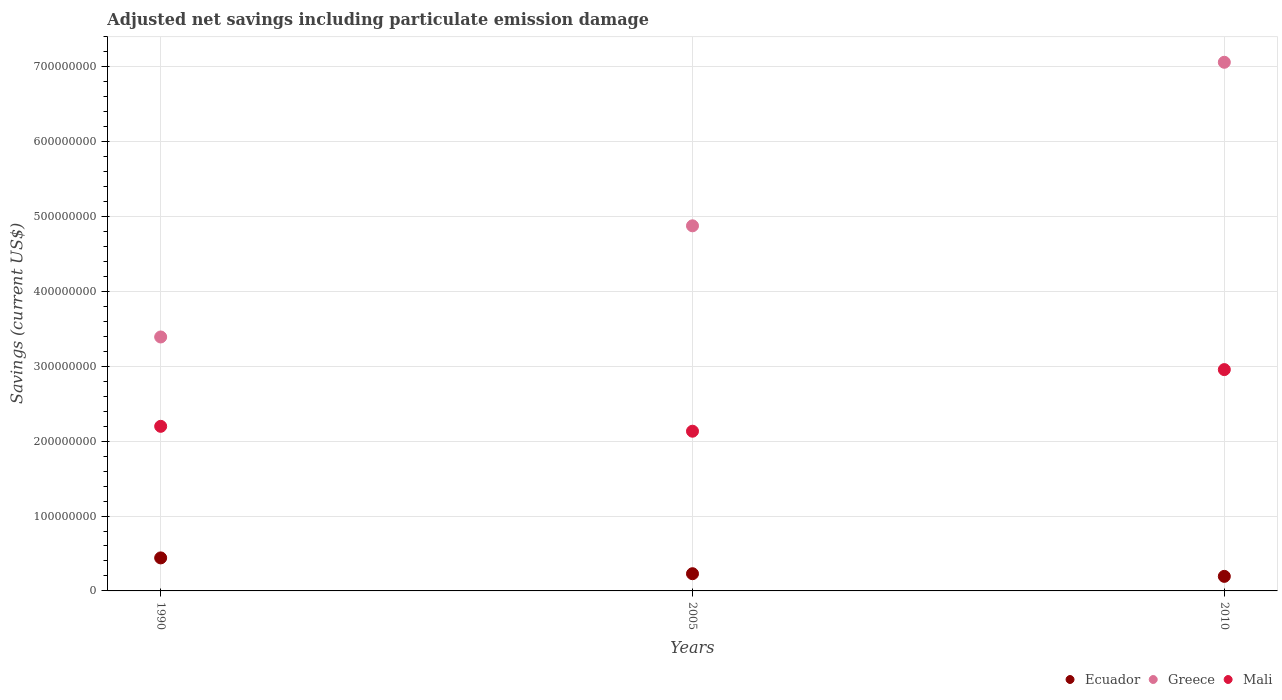Is the number of dotlines equal to the number of legend labels?
Give a very brief answer. Yes. What is the net savings in Greece in 2005?
Give a very brief answer. 4.88e+08. Across all years, what is the maximum net savings in Ecuador?
Ensure brevity in your answer.  4.41e+07. Across all years, what is the minimum net savings in Ecuador?
Offer a terse response. 1.94e+07. What is the total net savings in Mali in the graph?
Provide a short and direct response. 7.29e+08. What is the difference between the net savings in Ecuador in 1990 and that in 2010?
Provide a short and direct response. 2.47e+07. What is the difference between the net savings in Mali in 1990 and the net savings in Greece in 2010?
Provide a succinct answer. -4.86e+08. What is the average net savings in Greece per year?
Make the answer very short. 5.11e+08. In the year 2005, what is the difference between the net savings in Mali and net savings in Ecuador?
Provide a succinct answer. 1.90e+08. In how many years, is the net savings in Mali greater than 80000000 US$?
Keep it short and to the point. 3. What is the ratio of the net savings in Greece in 1990 to that in 2005?
Offer a terse response. 0.7. Is the net savings in Mali in 2005 less than that in 2010?
Your answer should be very brief. Yes. Is the difference between the net savings in Mali in 2005 and 2010 greater than the difference between the net savings in Ecuador in 2005 and 2010?
Provide a succinct answer. No. What is the difference between the highest and the second highest net savings in Ecuador?
Keep it short and to the point. 2.11e+07. What is the difference between the highest and the lowest net savings in Ecuador?
Provide a short and direct response. 2.47e+07. Is it the case that in every year, the sum of the net savings in Greece and net savings in Ecuador  is greater than the net savings in Mali?
Offer a very short reply. Yes. Is the net savings in Greece strictly greater than the net savings in Mali over the years?
Offer a very short reply. Yes. Does the graph contain any zero values?
Offer a terse response. No. Does the graph contain grids?
Your response must be concise. Yes. Where does the legend appear in the graph?
Give a very brief answer. Bottom right. What is the title of the graph?
Offer a terse response. Adjusted net savings including particulate emission damage. What is the label or title of the Y-axis?
Your answer should be very brief. Savings (current US$). What is the Savings (current US$) of Ecuador in 1990?
Give a very brief answer. 4.41e+07. What is the Savings (current US$) of Greece in 1990?
Offer a terse response. 3.39e+08. What is the Savings (current US$) of Mali in 1990?
Ensure brevity in your answer.  2.20e+08. What is the Savings (current US$) of Ecuador in 2005?
Your answer should be very brief. 2.30e+07. What is the Savings (current US$) of Greece in 2005?
Offer a very short reply. 4.88e+08. What is the Savings (current US$) of Mali in 2005?
Your response must be concise. 2.13e+08. What is the Savings (current US$) in Ecuador in 2010?
Provide a succinct answer. 1.94e+07. What is the Savings (current US$) of Greece in 2010?
Your response must be concise. 7.06e+08. What is the Savings (current US$) in Mali in 2010?
Make the answer very short. 2.96e+08. Across all years, what is the maximum Savings (current US$) in Ecuador?
Your response must be concise. 4.41e+07. Across all years, what is the maximum Savings (current US$) in Greece?
Offer a terse response. 7.06e+08. Across all years, what is the maximum Savings (current US$) of Mali?
Give a very brief answer. 2.96e+08. Across all years, what is the minimum Savings (current US$) of Ecuador?
Your answer should be compact. 1.94e+07. Across all years, what is the minimum Savings (current US$) of Greece?
Your response must be concise. 3.39e+08. Across all years, what is the minimum Savings (current US$) of Mali?
Keep it short and to the point. 2.13e+08. What is the total Savings (current US$) of Ecuador in the graph?
Give a very brief answer. 8.65e+07. What is the total Savings (current US$) of Greece in the graph?
Ensure brevity in your answer.  1.53e+09. What is the total Savings (current US$) in Mali in the graph?
Make the answer very short. 7.29e+08. What is the difference between the Savings (current US$) in Ecuador in 1990 and that in 2005?
Give a very brief answer. 2.11e+07. What is the difference between the Savings (current US$) in Greece in 1990 and that in 2005?
Offer a terse response. -1.48e+08. What is the difference between the Savings (current US$) in Mali in 1990 and that in 2005?
Offer a very short reply. 6.53e+06. What is the difference between the Savings (current US$) of Ecuador in 1990 and that in 2010?
Your answer should be compact. 2.47e+07. What is the difference between the Savings (current US$) in Greece in 1990 and that in 2010?
Your answer should be compact. -3.67e+08. What is the difference between the Savings (current US$) in Mali in 1990 and that in 2010?
Offer a very short reply. -7.58e+07. What is the difference between the Savings (current US$) in Ecuador in 2005 and that in 2010?
Your response must be concise. 3.54e+06. What is the difference between the Savings (current US$) of Greece in 2005 and that in 2010?
Your response must be concise. -2.18e+08. What is the difference between the Savings (current US$) in Mali in 2005 and that in 2010?
Make the answer very short. -8.23e+07. What is the difference between the Savings (current US$) of Ecuador in 1990 and the Savings (current US$) of Greece in 2005?
Give a very brief answer. -4.44e+08. What is the difference between the Savings (current US$) of Ecuador in 1990 and the Savings (current US$) of Mali in 2005?
Offer a very short reply. -1.69e+08. What is the difference between the Savings (current US$) of Greece in 1990 and the Savings (current US$) of Mali in 2005?
Ensure brevity in your answer.  1.26e+08. What is the difference between the Savings (current US$) in Ecuador in 1990 and the Savings (current US$) in Greece in 2010?
Ensure brevity in your answer.  -6.62e+08. What is the difference between the Savings (current US$) of Ecuador in 1990 and the Savings (current US$) of Mali in 2010?
Your answer should be very brief. -2.51e+08. What is the difference between the Savings (current US$) in Greece in 1990 and the Savings (current US$) in Mali in 2010?
Offer a very short reply. 4.36e+07. What is the difference between the Savings (current US$) of Ecuador in 2005 and the Savings (current US$) of Greece in 2010?
Give a very brief answer. -6.83e+08. What is the difference between the Savings (current US$) of Ecuador in 2005 and the Savings (current US$) of Mali in 2010?
Your answer should be very brief. -2.73e+08. What is the difference between the Savings (current US$) of Greece in 2005 and the Savings (current US$) of Mali in 2010?
Provide a succinct answer. 1.92e+08. What is the average Savings (current US$) in Ecuador per year?
Provide a short and direct response. 2.88e+07. What is the average Savings (current US$) of Greece per year?
Give a very brief answer. 5.11e+08. What is the average Savings (current US$) in Mali per year?
Give a very brief answer. 2.43e+08. In the year 1990, what is the difference between the Savings (current US$) in Ecuador and Savings (current US$) in Greece?
Make the answer very short. -2.95e+08. In the year 1990, what is the difference between the Savings (current US$) of Ecuador and Savings (current US$) of Mali?
Your answer should be compact. -1.76e+08. In the year 1990, what is the difference between the Savings (current US$) of Greece and Savings (current US$) of Mali?
Make the answer very short. 1.19e+08. In the year 2005, what is the difference between the Savings (current US$) of Ecuador and Savings (current US$) of Greece?
Keep it short and to the point. -4.65e+08. In the year 2005, what is the difference between the Savings (current US$) of Ecuador and Savings (current US$) of Mali?
Provide a succinct answer. -1.90e+08. In the year 2005, what is the difference between the Savings (current US$) of Greece and Savings (current US$) of Mali?
Your answer should be very brief. 2.74e+08. In the year 2010, what is the difference between the Savings (current US$) of Ecuador and Savings (current US$) of Greece?
Make the answer very short. -6.87e+08. In the year 2010, what is the difference between the Savings (current US$) in Ecuador and Savings (current US$) in Mali?
Offer a terse response. -2.76e+08. In the year 2010, what is the difference between the Savings (current US$) in Greece and Savings (current US$) in Mali?
Your answer should be very brief. 4.10e+08. What is the ratio of the Savings (current US$) of Ecuador in 1990 to that in 2005?
Give a very brief answer. 1.92. What is the ratio of the Savings (current US$) of Greece in 1990 to that in 2005?
Offer a very short reply. 0.7. What is the ratio of the Savings (current US$) of Mali in 1990 to that in 2005?
Provide a short and direct response. 1.03. What is the ratio of the Savings (current US$) in Ecuador in 1990 to that in 2010?
Provide a succinct answer. 2.27. What is the ratio of the Savings (current US$) in Greece in 1990 to that in 2010?
Your response must be concise. 0.48. What is the ratio of the Savings (current US$) of Mali in 1990 to that in 2010?
Your answer should be compact. 0.74. What is the ratio of the Savings (current US$) in Ecuador in 2005 to that in 2010?
Offer a terse response. 1.18. What is the ratio of the Savings (current US$) of Greece in 2005 to that in 2010?
Give a very brief answer. 0.69. What is the ratio of the Savings (current US$) in Mali in 2005 to that in 2010?
Offer a very short reply. 0.72. What is the difference between the highest and the second highest Savings (current US$) of Ecuador?
Keep it short and to the point. 2.11e+07. What is the difference between the highest and the second highest Savings (current US$) in Greece?
Offer a very short reply. 2.18e+08. What is the difference between the highest and the second highest Savings (current US$) of Mali?
Your answer should be compact. 7.58e+07. What is the difference between the highest and the lowest Savings (current US$) in Ecuador?
Provide a succinct answer. 2.47e+07. What is the difference between the highest and the lowest Savings (current US$) in Greece?
Your response must be concise. 3.67e+08. What is the difference between the highest and the lowest Savings (current US$) in Mali?
Offer a very short reply. 8.23e+07. 